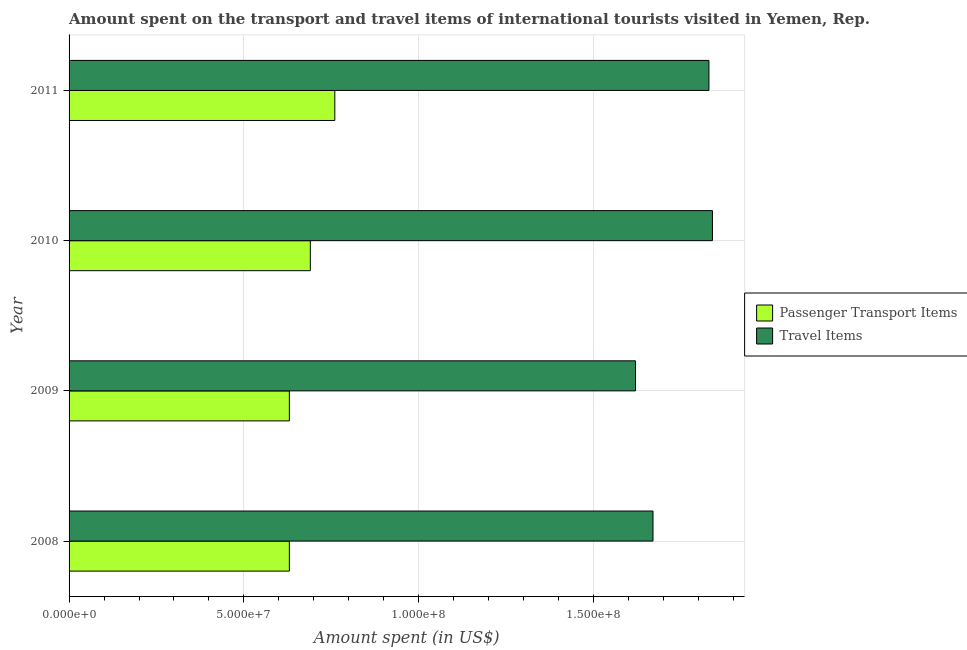How many groups of bars are there?
Keep it short and to the point. 4. Are the number of bars per tick equal to the number of legend labels?
Your answer should be compact. Yes. Are the number of bars on each tick of the Y-axis equal?
Provide a succinct answer. Yes. What is the label of the 2nd group of bars from the top?
Provide a succinct answer. 2010. In how many cases, is the number of bars for a given year not equal to the number of legend labels?
Your response must be concise. 0. What is the amount spent on passenger transport items in 2010?
Your answer should be compact. 6.90e+07. Across all years, what is the maximum amount spent in travel items?
Keep it short and to the point. 1.84e+08. Across all years, what is the minimum amount spent on passenger transport items?
Give a very brief answer. 6.30e+07. What is the total amount spent in travel items in the graph?
Make the answer very short. 6.96e+08. What is the difference between the amount spent on passenger transport items in 2008 and that in 2010?
Your response must be concise. -6.00e+06. What is the difference between the amount spent in travel items in 2011 and the amount spent on passenger transport items in 2009?
Offer a terse response. 1.20e+08. What is the average amount spent in travel items per year?
Make the answer very short. 1.74e+08. In the year 2011, what is the difference between the amount spent in travel items and amount spent on passenger transport items?
Offer a very short reply. 1.07e+08. In how many years, is the amount spent in travel items greater than 160000000 US$?
Keep it short and to the point. 4. What is the ratio of the amount spent in travel items in 2009 to that in 2011?
Offer a very short reply. 0.89. What is the difference between the highest and the lowest amount spent in travel items?
Offer a very short reply. 2.20e+07. In how many years, is the amount spent on passenger transport items greater than the average amount spent on passenger transport items taken over all years?
Make the answer very short. 2. Is the sum of the amount spent in travel items in 2009 and 2011 greater than the maximum amount spent on passenger transport items across all years?
Offer a very short reply. Yes. What does the 1st bar from the top in 2011 represents?
Your answer should be compact. Travel Items. What does the 2nd bar from the bottom in 2010 represents?
Provide a short and direct response. Travel Items. Are the values on the major ticks of X-axis written in scientific E-notation?
Give a very brief answer. Yes. How many legend labels are there?
Ensure brevity in your answer.  2. How are the legend labels stacked?
Your answer should be very brief. Vertical. What is the title of the graph?
Offer a very short reply. Amount spent on the transport and travel items of international tourists visited in Yemen, Rep. Does "Money lenders" appear as one of the legend labels in the graph?
Your answer should be compact. No. What is the label or title of the X-axis?
Make the answer very short. Amount spent (in US$). What is the Amount spent (in US$) in Passenger Transport Items in 2008?
Provide a short and direct response. 6.30e+07. What is the Amount spent (in US$) of Travel Items in 2008?
Offer a terse response. 1.67e+08. What is the Amount spent (in US$) of Passenger Transport Items in 2009?
Offer a terse response. 6.30e+07. What is the Amount spent (in US$) of Travel Items in 2009?
Keep it short and to the point. 1.62e+08. What is the Amount spent (in US$) of Passenger Transport Items in 2010?
Keep it short and to the point. 6.90e+07. What is the Amount spent (in US$) of Travel Items in 2010?
Your answer should be compact. 1.84e+08. What is the Amount spent (in US$) in Passenger Transport Items in 2011?
Ensure brevity in your answer.  7.60e+07. What is the Amount spent (in US$) in Travel Items in 2011?
Your answer should be compact. 1.83e+08. Across all years, what is the maximum Amount spent (in US$) in Passenger Transport Items?
Offer a very short reply. 7.60e+07. Across all years, what is the maximum Amount spent (in US$) of Travel Items?
Your response must be concise. 1.84e+08. Across all years, what is the minimum Amount spent (in US$) in Passenger Transport Items?
Offer a terse response. 6.30e+07. Across all years, what is the minimum Amount spent (in US$) in Travel Items?
Ensure brevity in your answer.  1.62e+08. What is the total Amount spent (in US$) in Passenger Transport Items in the graph?
Your response must be concise. 2.71e+08. What is the total Amount spent (in US$) in Travel Items in the graph?
Give a very brief answer. 6.96e+08. What is the difference between the Amount spent (in US$) of Passenger Transport Items in 2008 and that in 2009?
Give a very brief answer. 0. What is the difference between the Amount spent (in US$) of Travel Items in 2008 and that in 2009?
Your response must be concise. 5.00e+06. What is the difference between the Amount spent (in US$) of Passenger Transport Items in 2008 and that in 2010?
Provide a short and direct response. -6.00e+06. What is the difference between the Amount spent (in US$) of Travel Items in 2008 and that in 2010?
Your answer should be very brief. -1.70e+07. What is the difference between the Amount spent (in US$) in Passenger Transport Items in 2008 and that in 2011?
Keep it short and to the point. -1.30e+07. What is the difference between the Amount spent (in US$) of Travel Items in 2008 and that in 2011?
Your answer should be compact. -1.60e+07. What is the difference between the Amount spent (in US$) of Passenger Transport Items in 2009 and that in 2010?
Your response must be concise. -6.00e+06. What is the difference between the Amount spent (in US$) of Travel Items in 2009 and that in 2010?
Offer a terse response. -2.20e+07. What is the difference between the Amount spent (in US$) of Passenger Transport Items in 2009 and that in 2011?
Provide a succinct answer. -1.30e+07. What is the difference between the Amount spent (in US$) of Travel Items in 2009 and that in 2011?
Your answer should be compact. -2.10e+07. What is the difference between the Amount spent (in US$) of Passenger Transport Items in 2010 and that in 2011?
Provide a short and direct response. -7.00e+06. What is the difference between the Amount spent (in US$) of Passenger Transport Items in 2008 and the Amount spent (in US$) of Travel Items in 2009?
Your response must be concise. -9.90e+07. What is the difference between the Amount spent (in US$) in Passenger Transport Items in 2008 and the Amount spent (in US$) in Travel Items in 2010?
Provide a short and direct response. -1.21e+08. What is the difference between the Amount spent (in US$) of Passenger Transport Items in 2008 and the Amount spent (in US$) of Travel Items in 2011?
Give a very brief answer. -1.20e+08. What is the difference between the Amount spent (in US$) in Passenger Transport Items in 2009 and the Amount spent (in US$) in Travel Items in 2010?
Your response must be concise. -1.21e+08. What is the difference between the Amount spent (in US$) of Passenger Transport Items in 2009 and the Amount spent (in US$) of Travel Items in 2011?
Provide a succinct answer. -1.20e+08. What is the difference between the Amount spent (in US$) of Passenger Transport Items in 2010 and the Amount spent (in US$) of Travel Items in 2011?
Provide a short and direct response. -1.14e+08. What is the average Amount spent (in US$) in Passenger Transport Items per year?
Your answer should be very brief. 6.78e+07. What is the average Amount spent (in US$) of Travel Items per year?
Provide a succinct answer. 1.74e+08. In the year 2008, what is the difference between the Amount spent (in US$) of Passenger Transport Items and Amount spent (in US$) of Travel Items?
Ensure brevity in your answer.  -1.04e+08. In the year 2009, what is the difference between the Amount spent (in US$) of Passenger Transport Items and Amount spent (in US$) of Travel Items?
Keep it short and to the point. -9.90e+07. In the year 2010, what is the difference between the Amount spent (in US$) in Passenger Transport Items and Amount spent (in US$) in Travel Items?
Provide a short and direct response. -1.15e+08. In the year 2011, what is the difference between the Amount spent (in US$) in Passenger Transport Items and Amount spent (in US$) in Travel Items?
Offer a terse response. -1.07e+08. What is the ratio of the Amount spent (in US$) of Passenger Transport Items in 2008 to that in 2009?
Provide a short and direct response. 1. What is the ratio of the Amount spent (in US$) in Travel Items in 2008 to that in 2009?
Provide a succinct answer. 1.03. What is the ratio of the Amount spent (in US$) of Travel Items in 2008 to that in 2010?
Offer a very short reply. 0.91. What is the ratio of the Amount spent (in US$) of Passenger Transport Items in 2008 to that in 2011?
Give a very brief answer. 0.83. What is the ratio of the Amount spent (in US$) of Travel Items in 2008 to that in 2011?
Your response must be concise. 0.91. What is the ratio of the Amount spent (in US$) in Passenger Transport Items in 2009 to that in 2010?
Offer a very short reply. 0.91. What is the ratio of the Amount spent (in US$) in Travel Items in 2009 to that in 2010?
Ensure brevity in your answer.  0.88. What is the ratio of the Amount spent (in US$) in Passenger Transport Items in 2009 to that in 2011?
Make the answer very short. 0.83. What is the ratio of the Amount spent (in US$) of Travel Items in 2009 to that in 2011?
Your answer should be compact. 0.89. What is the ratio of the Amount spent (in US$) in Passenger Transport Items in 2010 to that in 2011?
Give a very brief answer. 0.91. What is the ratio of the Amount spent (in US$) in Travel Items in 2010 to that in 2011?
Make the answer very short. 1.01. What is the difference between the highest and the second highest Amount spent (in US$) of Passenger Transport Items?
Your response must be concise. 7.00e+06. What is the difference between the highest and the lowest Amount spent (in US$) in Passenger Transport Items?
Keep it short and to the point. 1.30e+07. What is the difference between the highest and the lowest Amount spent (in US$) of Travel Items?
Provide a short and direct response. 2.20e+07. 